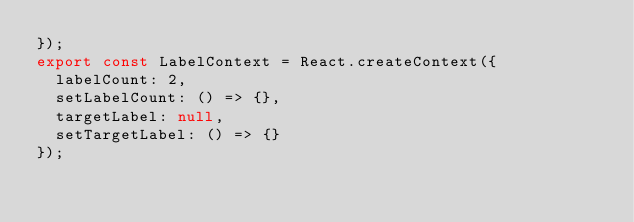Convert code to text. <code><loc_0><loc_0><loc_500><loc_500><_JavaScript_>});
export const LabelContext = React.createContext({
  labelCount: 2,
  setLabelCount: () => {},
  targetLabel: null,
  setTargetLabel: () => {}
});
</code> 